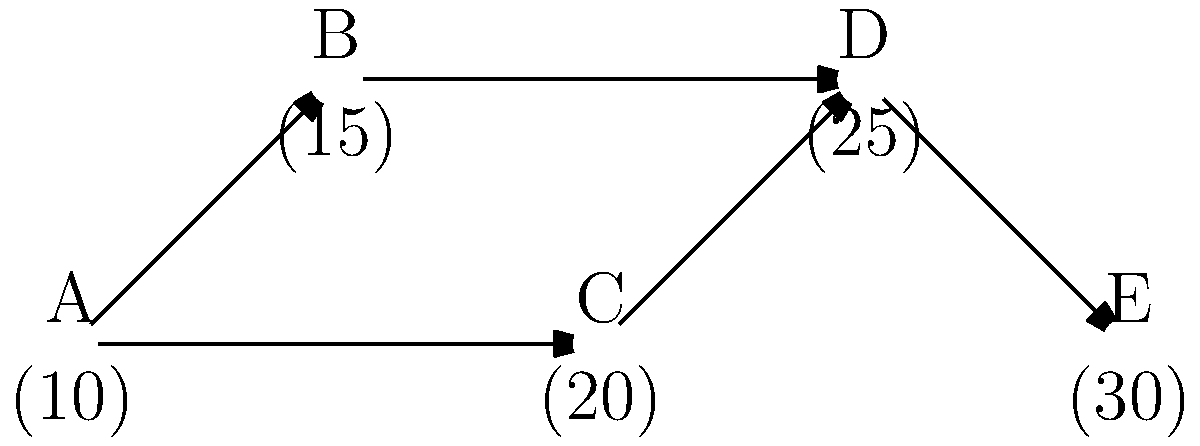In the network shown above, nodes represent routers with their capacities (in packets/second) given in parentheses. You need to route 40 packets/second from node A to node E. What is the maximum flow that can be achieved through this network without exceeding any node's capacity? To solve this problem, we need to find the maximum flow from node A to node E while respecting the capacity constraints of each node. Let's approach this step-by-step:

1) First, identify the possible paths from A to E:
   Path 1: A → B → D → E
   Path 2: A → C → D → E

2) Now, let's consider the capacities along each path:
   Path 1: min(10, 15, 25, 30) = 10
   Path 2: min(10, 20, 25, 30) = 10

3) We can send up to 10 packets/second through each path without exceeding any node's capacity.

4) However, both paths converge at node D, which has a capacity of 25 packets/second. This becomes our bottleneck.

5) Therefore, the maximum flow we can achieve is 25 packets/second:
   - 10 packets/second through Path 1 (A → B → D → E)
   - 15 packets/second through Path 2 (A → C → D → E)

6) This solution respects all node capacities:
   A: 10 + 15 = 25 ≤ 30
   B: 10 ≤ 15
   C: 15 ≤ 20
   D: 25 = 25
   E: 25 ≤ 30

Thus, the maximum flow that can be achieved is 25 packets/second.
Answer: 25 packets/second 